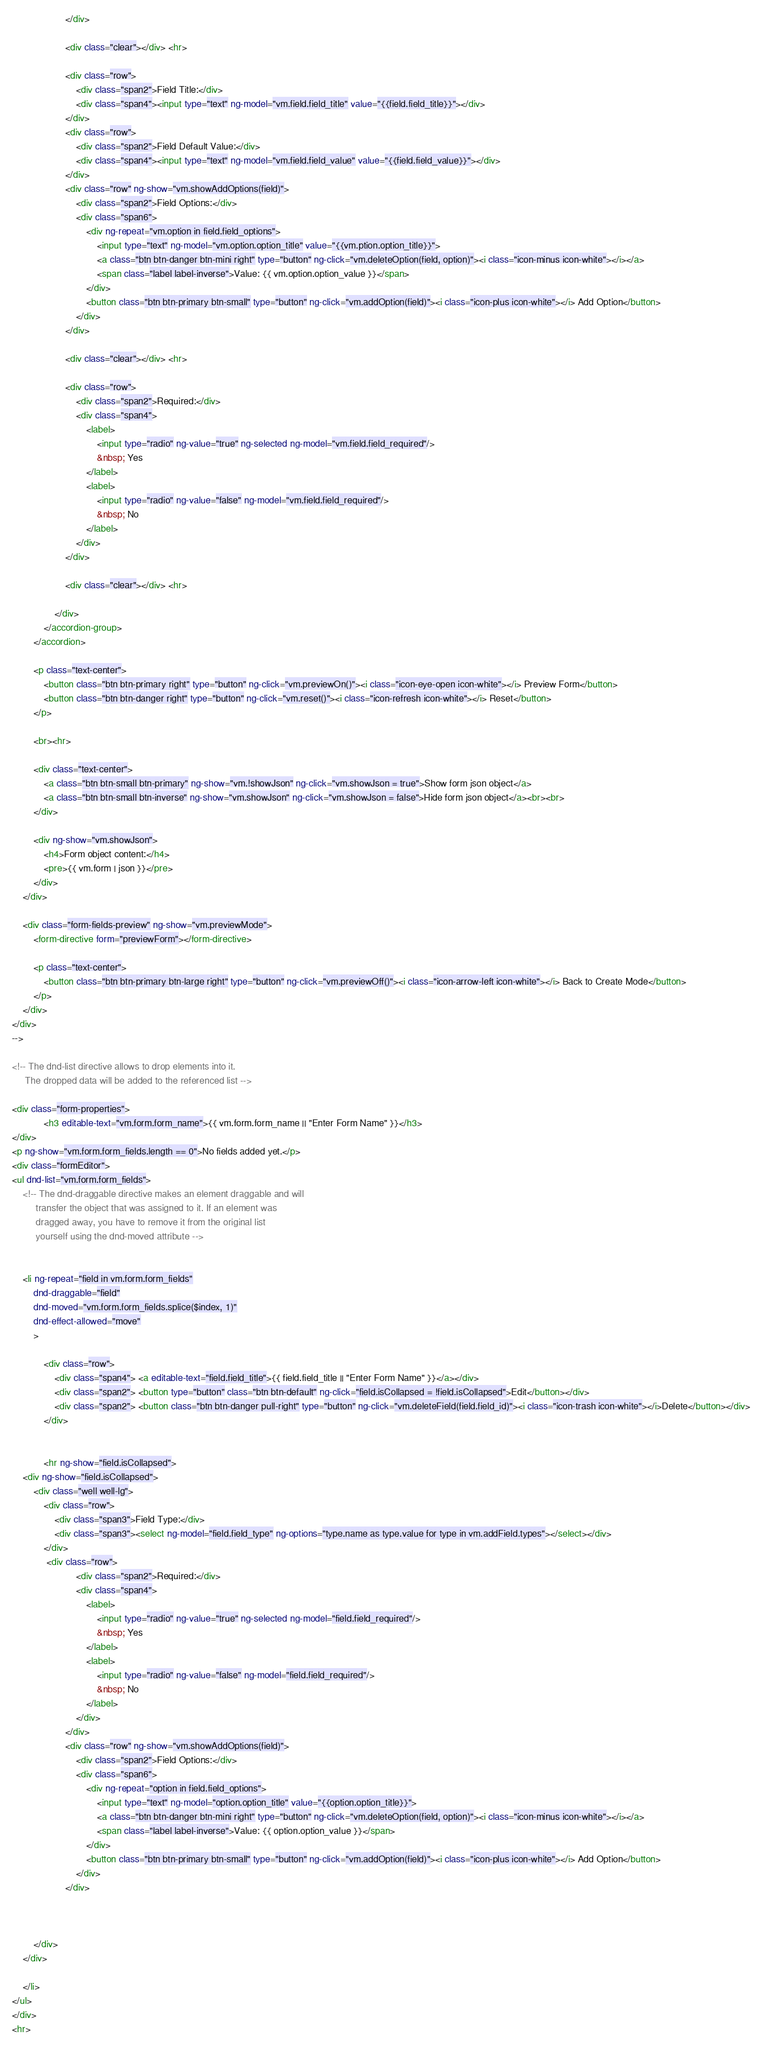<code> <loc_0><loc_0><loc_500><loc_500><_HTML_>                    </div>

                    <div class="clear"></div> <hr>

                    <div class="row">
                        <div class="span2">Field Title:</div>
                        <div class="span4"><input type="text" ng-model="vm.field.field_title" value="{{field.field_title}}"></div>
                    </div>
                    <div class="row">
                        <div class="span2">Field Default Value:</div>
                        <div class="span4"><input type="text" ng-model="vm.field.field_value" value="{{field.field_value}}"></div>
                    </div>
                    <div class="row" ng-show="vm.showAddOptions(field)">
                        <div class="span2">Field Options:</div>
                        <div class="span6">
                            <div ng-repeat="vm.option in field.field_options">
                                <input type="text" ng-model="vm.option.option_title" value="{{vm.ption.option_title}}">
                                <a class="btn btn-danger btn-mini right" type="button" ng-click="vm.deleteOption(field, option)"><i class="icon-minus icon-white"></i></a>
                                <span class="label label-inverse">Value: {{ vm.option.option_value }}</span>
                            </div>
                            <button class="btn btn-primary btn-small" type="button" ng-click="vm.addOption(field)"><i class="icon-plus icon-white"></i> Add Option</button>
                        </div>
                    </div>

					<div class="clear"></div> <hr>

                    <div class="row">
                        <div class="span2">Required:</div>
                        <div class="span4">
                            <label>
                                <input type="radio" ng-value="true" ng-selected ng-model="vm.field.field_required"/>
                                &nbsp; Yes
                            </label>
                            <label>
                                <input type="radio" ng-value="false" ng-model="vm.field.field_required"/>
                                &nbsp; No
                            </label>
                        </div>
                    </div>
					
					<div class="clear"></div> <hr>

                </div>
            </accordion-group>
        </accordion>

        <p class="text-center">
            <button class="btn btn-primary right" type="button" ng-click="vm.previewOn()"><i class="icon-eye-open icon-white"></i> Preview Form</button>
            <button class="btn btn-danger right" type="button" ng-click="vm.reset()"><i class="icon-refresh icon-white"></i> Reset</button>
        </p>

        <br><hr>

		<div class="text-center">
			<a class="btn btn-small btn-primary" ng-show="vm.!showJson" ng-click="vm.showJson = true">Show form json object</a>
			<a class="btn btn-small btn-inverse" ng-show="vm.showJson" ng-click="vm.showJson = false">Hide form json object</a><br><br>
		</div>

        <div ng-show="vm.showJson">
            <h4>Form object content:</h4>
            <pre>{{ vm.form | json }}</pre>
        </div>
    </div>

    <div class="form-fields-preview" ng-show="vm.previewMode">
        <form-directive form="previewForm"></form-directive>

        <p class="text-center">
            <button class="btn btn-primary btn-large right" type="button" ng-click="vm.previewOff()"><i class="icon-arrow-left icon-white"></i> Back to Create Mode</button>
        </p>
    </div>
</div>
-->

<!-- The dnd-list directive allows to drop elements into it.
     The dropped data will be added to the referenced list -->

<div class="form-properties">
            <h3 editable-text="vm.form.form_name">{{ vm.form.form_name || "Enter Form Name" }}</h3>
</div>
<p ng-show="vm.form.form_fields.length == 0">No fields added yet.</p>
<div class="formEditor">
<ul dnd-list="vm.form.form_fields">
    <!-- The dnd-draggable directive makes an element draggable and will
         transfer the object that was assigned to it. If an element was
         dragged away, you have to remove it from the original list
         yourself using the dnd-moved attribute -->


    <li ng-repeat="field in vm.form.form_fields"
        dnd-draggable="field"
        dnd-moved="vm.form.form_fields.splice($index, 1)"
        dnd-effect-allowed="move"
        >

            <div class="row">
                <div class="span4"> <a editable-text="field.field_title">{{ field.field_title || "Enter Form Name" }}</a></div>
                <div class="span2"> <button type="button" class="btn btn-default" ng-click="field.isCollapsed = !field.isCollapsed">Edit</button></div>
                <div class="span2"> <button class="btn btn-danger pull-right" type="button" ng-click="vm.deleteField(field.field_id)"><i class="icon-trash icon-white"></i>Delete</button></div>
            </div>


	        <hr ng-show="field.isCollapsed">
	<div ng-show="field.isCollapsed">
		<div class="well well-lg">
            <div class="row">
                <div class="span3">Field Type:</div>
                <div class="span3"><select ng-model="field.field_type" ng-options="type.name as type.value for type in vm.addField.types"></select></div>
            </div>
             <div class="row">
                        <div class="span2">Required:</div>
                        <div class="span4">
                            <label>
                                <input type="radio" ng-value="true" ng-selected ng-model="field.field_required"/>
                                &nbsp; Yes
                            </label>
                            <label>
                                <input type="radio" ng-value="false" ng-model="field.field_required"/>
                                &nbsp; No
                            </label>
                        </div>
                    </div>
                    <div class="row" ng-show="vm.showAddOptions(field)">
                        <div class="span2">Field Options:</div>
                        <div class="span6">
                            <div ng-repeat="option in field.field_options">
                                <input type="text" ng-model="option.option_title" value="{{option.option_title}}">
                                <a class="btn btn-danger btn-mini right" type="button" ng-click="vm.deleteOption(field, option)"><i class="icon-minus icon-white"></i></a>
                                <span class="label label-inverse">Value: {{ option.option_value }}</span>
                            </div>
                            <button class="btn btn-primary btn-small" type="button" ng-click="vm.addOption(field)"><i class="icon-plus icon-white"></i> Add Option</button>
                        </div>
                    </div>



        </div>
	</div>

    </li>
</ul>
</div>
<hr></code> 